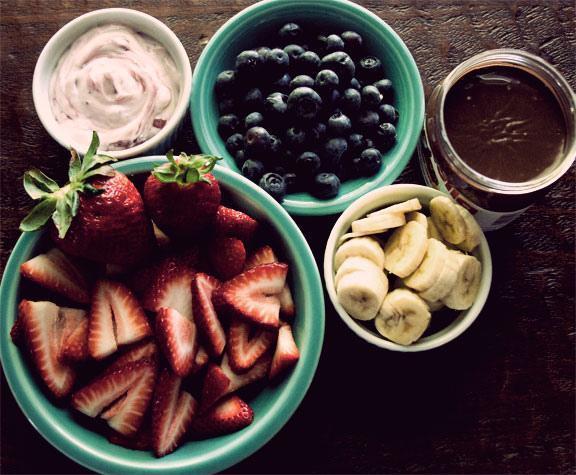How many bowls are there?
Give a very brief answer. 4. 